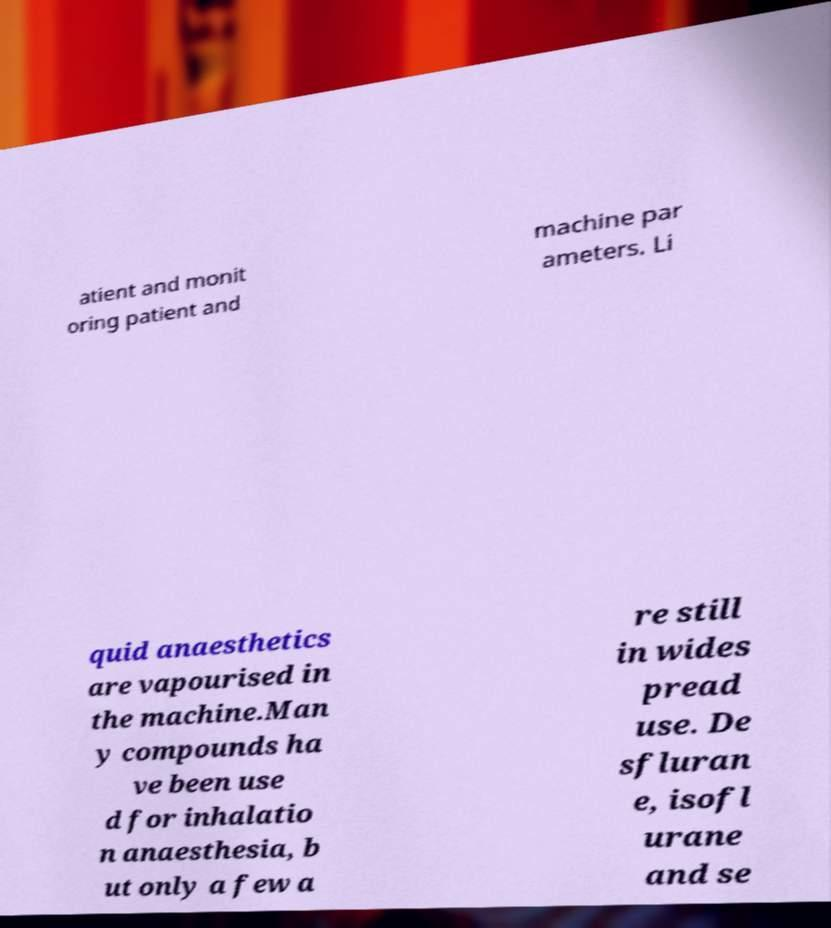Please identify and transcribe the text found in this image. atient and monit oring patient and machine par ameters. Li quid anaesthetics are vapourised in the machine.Man y compounds ha ve been use d for inhalatio n anaesthesia, b ut only a few a re still in wides pread use. De sfluran e, isofl urane and se 